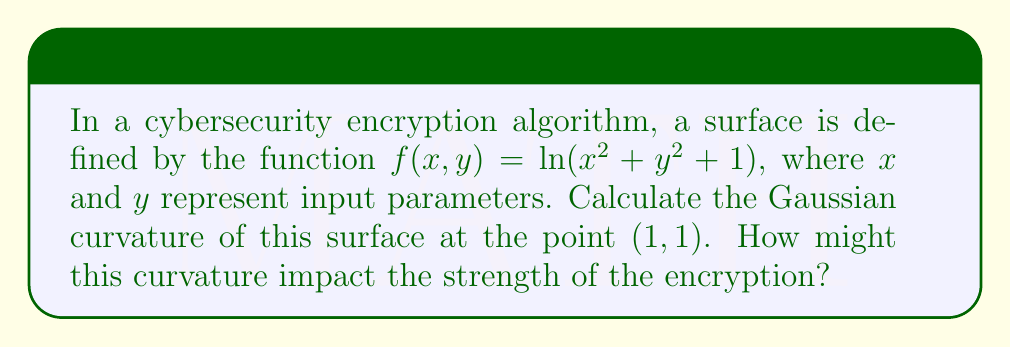Can you solve this math problem? To calculate the Gaussian curvature, we need to follow these steps:

1) First, we need to calculate the first and second partial derivatives of $f(x,y)$:

   $f_x = \frac{2x}{x^2 + y^2 + 1}$
   $f_y = \frac{2y}{x^2 + y^2 + 1}$
   
   $f_{xx} = \frac{2(x^2 + y^2 + 1) - 4x^2}{(x^2 + y^2 + 1)^2}$
   $f_{yy} = \frac{2(x^2 + y^2 + 1) - 4y^2}{(x^2 + y^2 + 1)^2}$
   $f_{xy} = f_{yx} = \frac{-4xy}{(x^2 + y^2 + 1)^2}$

2) The Gaussian curvature K is given by the formula:

   $$K = \frac{f_{xx}f_{yy} - f_{xy}^2}{(1 + f_x^2 + f_y^2)^2}$$

3) Let's substitute the point (1,1):

   $f_x(1,1) = f_y(1,1) = \frac{2}{3}$
   
   $f_{xx}(1,1) = f_{yy}(1,1) = \frac{2(3) - 4}{3^2} = -\frac{2}{9}$
   
   $f_{xy}(1,1) = \frac{-4}{9}$

4) Now we can calculate K:

   $$K = \frac{(-\frac{2}{9})(-\frac{2}{9}) - (\frac{-4}{9})^2}{(1 + (\frac{2}{3})^2 + (\frac{2}{3})^2)^2}$$

5) Simplify:

   $$K = \frac{\frac{4}{81} - \frac{16}{81}}{(\frac{13}{9})^2} = \frac{-\frac{12}{81}}{\frac{169}{81}} = -\frac{12}{169}$$

The negative Gaussian curvature at (1,1) indicates that the surface has a saddle-like shape at this point. In terms of encryption strength, this curvature might represent a complex relationship between input parameters, potentially making it harder for attackers to predict or reverse-engineer the encryption process.
Answer: $K = -\frac{12}{169}$ 